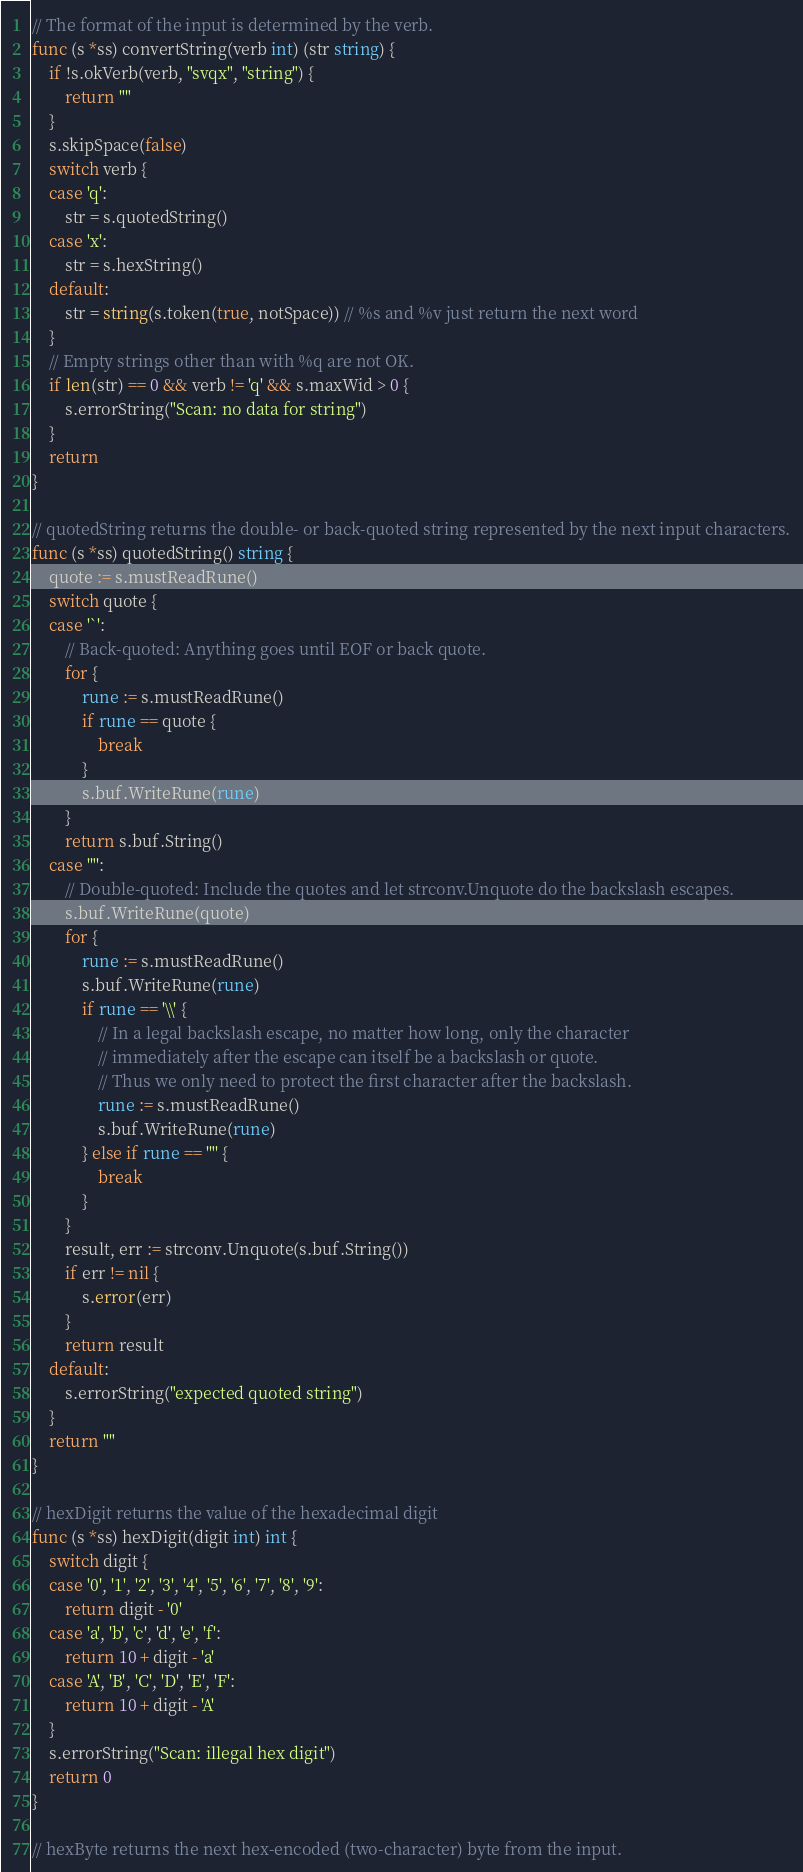<code> <loc_0><loc_0><loc_500><loc_500><_Go_>// The format of the input is determined by the verb.
func (s *ss) convertString(verb int) (str string) {
	if !s.okVerb(verb, "svqx", "string") {
		return ""
	}
	s.skipSpace(false)
	switch verb {
	case 'q':
		str = s.quotedString()
	case 'x':
		str = s.hexString()
	default:
		str = string(s.token(true, notSpace)) // %s and %v just return the next word
	}
	// Empty strings other than with %q are not OK.
	if len(str) == 0 && verb != 'q' && s.maxWid > 0 {
		s.errorString("Scan: no data for string")
	}
	return
}

// quotedString returns the double- or back-quoted string represented by the next input characters.
func (s *ss) quotedString() string {
	quote := s.mustReadRune()
	switch quote {
	case '`':
		// Back-quoted: Anything goes until EOF or back quote.
		for {
			rune := s.mustReadRune()
			if rune == quote {
				break
			}
			s.buf.WriteRune(rune)
		}
		return s.buf.String()
	case '"':
		// Double-quoted: Include the quotes and let strconv.Unquote do the backslash escapes.
		s.buf.WriteRune(quote)
		for {
			rune := s.mustReadRune()
			s.buf.WriteRune(rune)
			if rune == '\\' {
				// In a legal backslash escape, no matter how long, only the character
				// immediately after the escape can itself be a backslash or quote.
				// Thus we only need to protect the first character after the backslash.
				rune := s.mustReadRune()
				s.buf.WriteRune(rune)
			} else if rune == '"' {
				break
			}
		}
		result, err := strconv.Unquote(s.buf.String())
		if err != nil {
			s.error(err)
		}
		return result
	default:
		s.errorString("expected quoted string")
	}
	return ""
}

// hexDigit returns the value of the hexadecimal digit
func (s *ss) hexDigit(digit int) int {
	switch digit {
	case '0', '1', '2', '3', '4', '5', '6', '7', '8', '9':
		return digit - '0'
	case 'a', 'b', 'c', 'd', 'e', 'f':
		return 10 + digit - 'a'
	case 'A', 'B', 'C', 'D', 'E', 'F':
		return 10 + digit - 'A'
	}
	s.errorString("Scan: illegal hex digit")
	return 0
}

// hexByte returns the next hex-encoded (two-character) byte from the input.</code> 